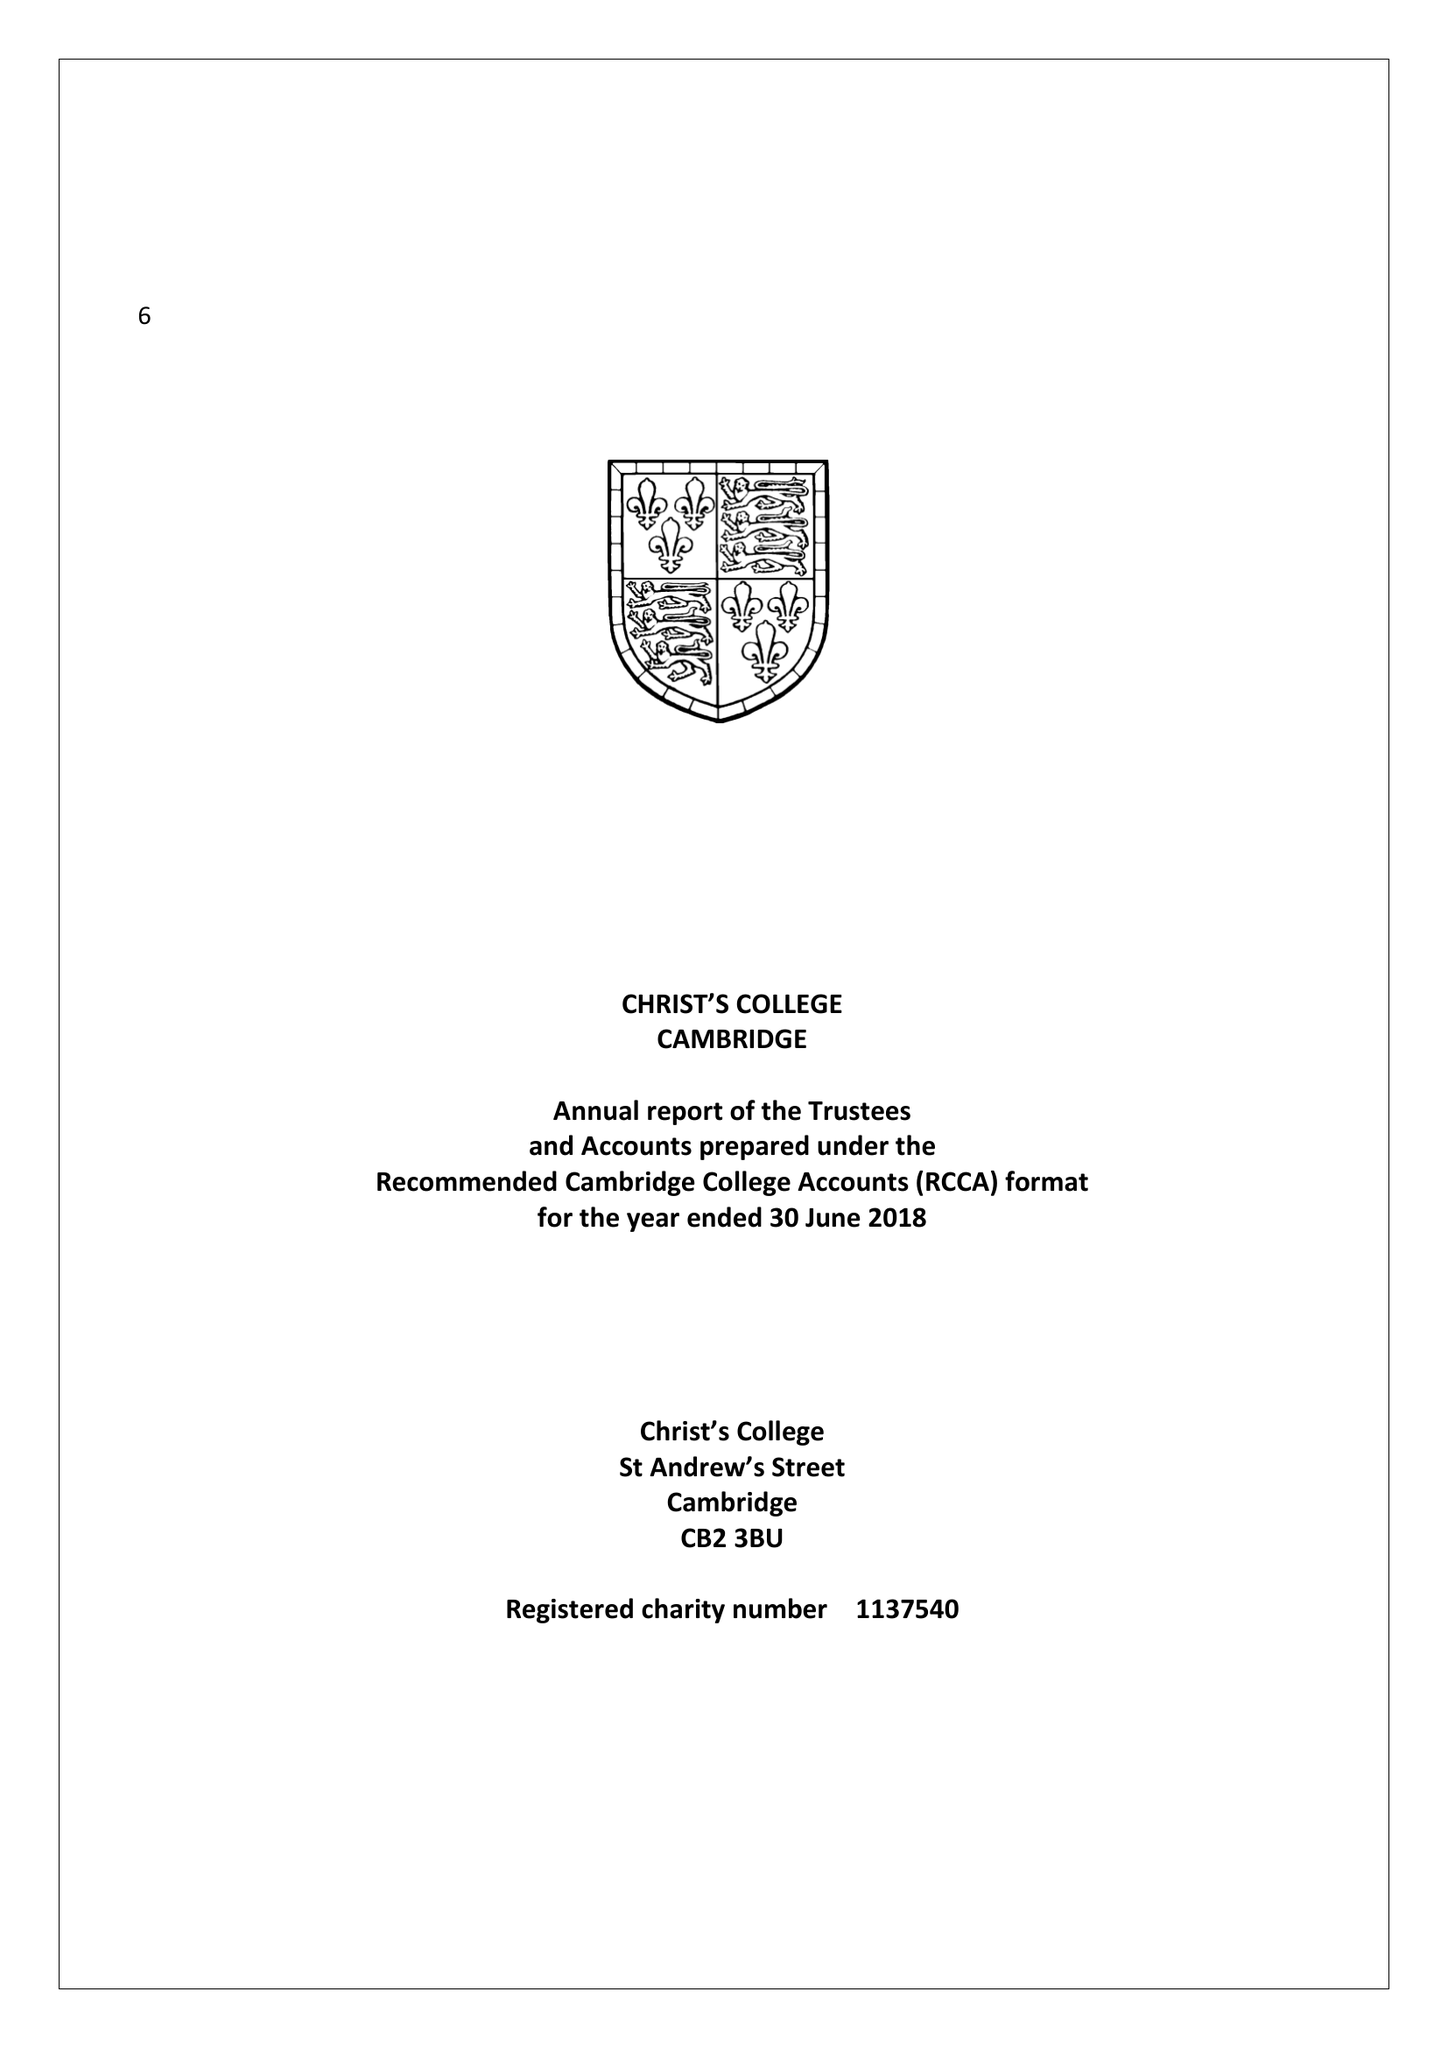What is the value for the address__post_town?
Answer the question using a single word or phrase. CAMBRIDGE 